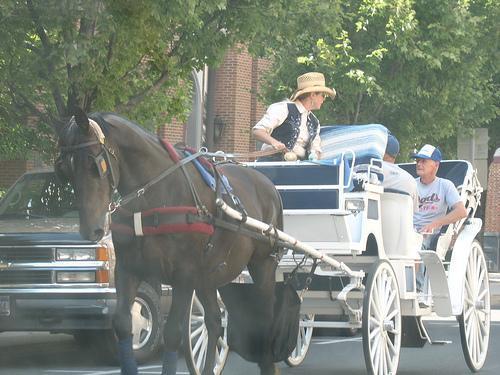How many persons are wear hats in this picture?
Give a very brief answer. 3. How many people are there?
Give a very brief answer. 2. 